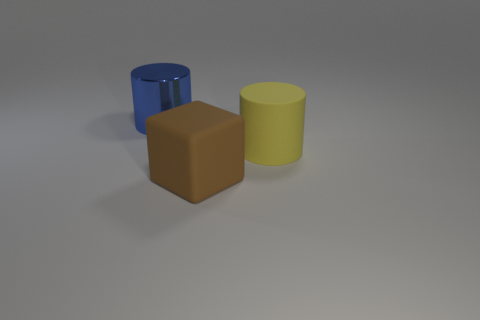Subtract all gray cylinders. Subtract all cyan cubes. How many cylinders are left? 2 Add 3 yellow rubber things. How many objects exist? 6 Subtract all cubes. How many objects are left? 2 Subtract 0 blue cubes. How many objects are left? 3 Subtract all big brown matte things. Subtract all yellow rubber objects. How many objects are left? 1 Add 1 rubber blocks. How many rubber blocks are left? 2 Add 3 tiny cylinders. How many tiny cylinders exist? 3 